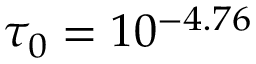Convert formula to latex. <formula><loc_0><loc_0><loc_500><loc_500>\tau _ { 0 } = 1 0 ^ { - 4 . 7 6 }</formula> 